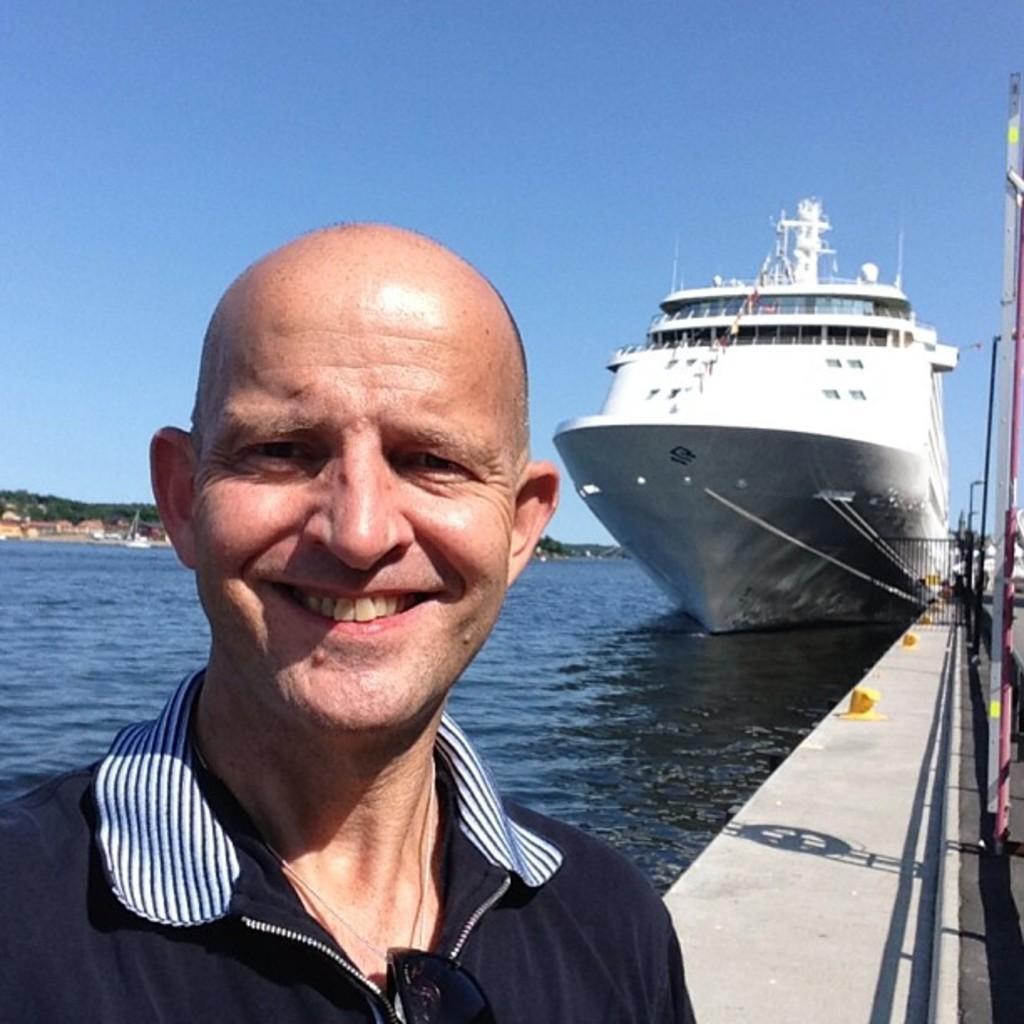How would you summarize this image in a sentence or two? In this image there is the sky, there is a person, there is a sea, there is a ship, there are objects truncated to the right of the image. 